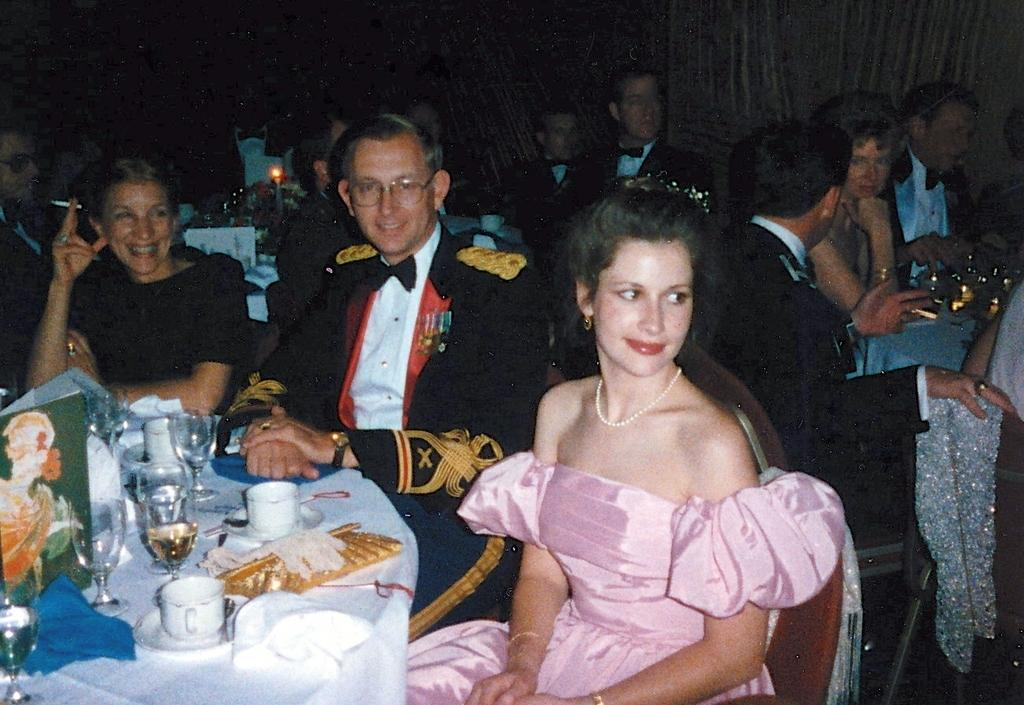What is happening in the image? There are people sitting around a table in the image. What objects can be seen on the table? There are glasses and coffee cups on the table. How many types of beverage containers are on the table? There are two types of beverage containers: glasses and coffee cups. How does the ice shake the table in the image? There is no ice present in the image, and therefore no shaking of the table can be observed. 